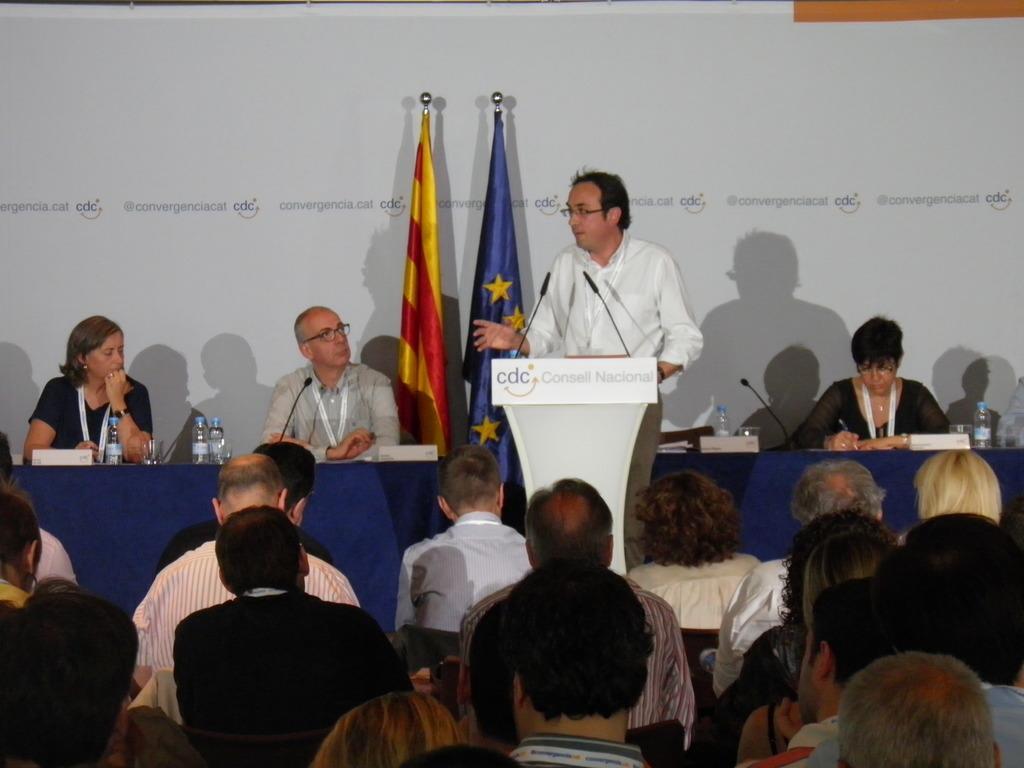Please provide a concise description of this image. This picture is clicked outside. In the center we can see the group of persons sitting on the chairs and there is a table on the top of which microphones, water bottles, glasses and many other items are placed and we can see a person wearing white color shirt and standing behind the podium and we can see the microphones are attached to the podium. In the background there is a white color object on which we can see the text and we can see the two flags. 